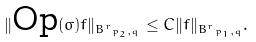<formula> <loc_0><loc_0><loc_500><loc_500>\| \text {Op} ( \sigma ) f \| _ { { B ^ { r } } _ { p _ { 2 } , q } } \leq C \| f \| _ { { B ^ { r } } _ { p _ { 1 } , q } } .</formula> 